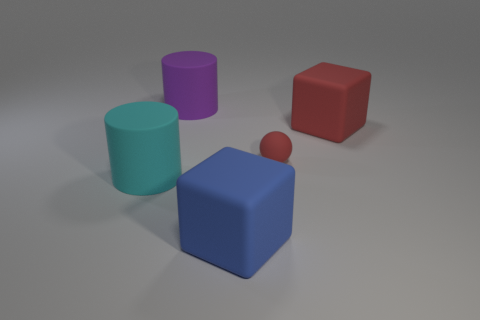What number of rubber things are to the right of the purple matte cylinder and behind the large cyan rubber cylinder?
Your answer should be very brief. 2. What is the color of the large cube behind the blue thing?
Your answer should be very brief. Red. The purple cylinder that is made of the same material as the large cyan thing is what size?
Provide a succinct answer. Large. There is a large thing in front of the large cyan cylinder; how many large rubber blocks are on the left side of it?
Your answer should be compact. 0. How many large rubber things are to the right of the cyan rubber cylinder?
Give a very brief answer. 3. There is a big object that is behind the rubber cube that is behind the matte cube that is in front of the ball; what color is it?
Give a very brief answer. Purple. Is the color of the large matte block on the right side of the red matte ball the same as the ball in front of the purple thing?
Your answer should be compact. Yes. What is the shape of the cyan thing that is left of the block in front of the red rubber block?
Keep it short and to the point. Cylinder. Are there any cyan matte blocks of the same size as the purple cylinder?
Make the answer very short. No. What number of other things are the same shape as the big blue thing?
Provide a short and direct response. 1. 